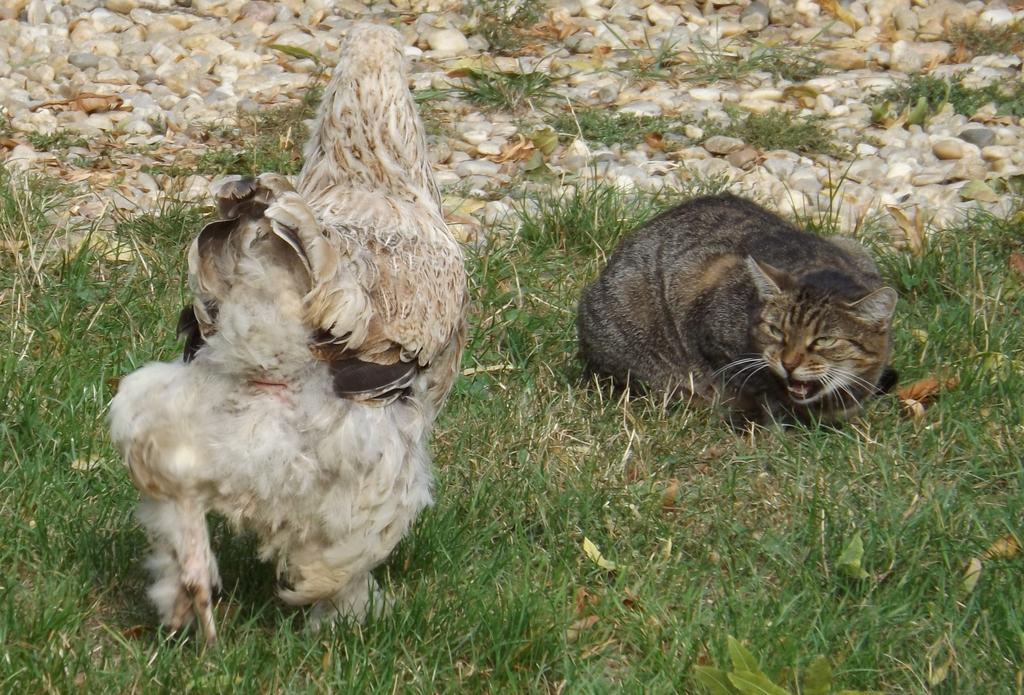What animals can be seen in the image? There is a cat and a hen in the image. Where are the cat and the hen located in the image? Both the cat and the hen are on the ground in the image. What type of vegetation is visible in the image? There is grass visible in the image. What else can be seen on the ground in the image? There are stones in the image. What type of trick does the cat perform with the drawer in the image? There is no drawer present in the image, and therefore no trick involving a drawer can be observed. 